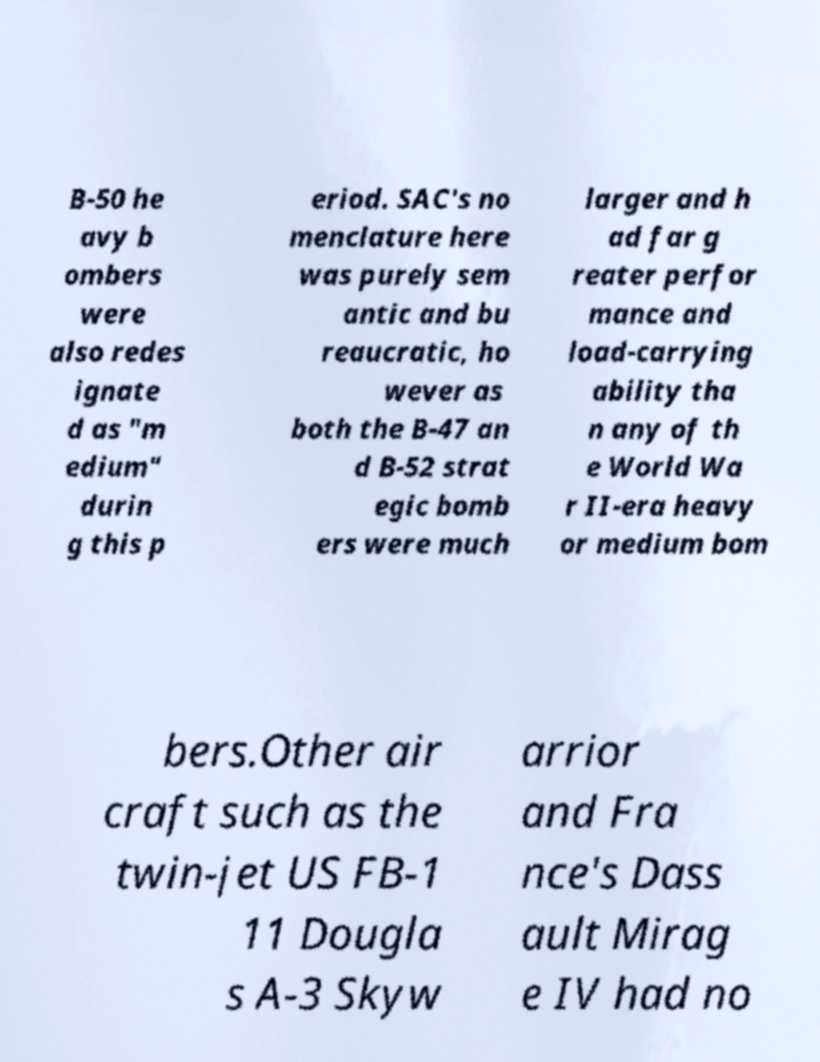Could you extract and type out the text from this image? B-50 he avy b ombers were also redes ignate d as "m edium" durin g this p eriod. SAC's no menclature here was purely sem antic and bu reaucratic, ho wever as both the B-47 an d B-52 strat egic bomb ers were much larger and h ad far g reater perfor mance and load-carrying ability tha n any of th e World Wa r II-era heavy or medium bom bers.Other air craft such as the twin-jet US FB-1 11 Dougla s A-3 Skyw arrior and Fra nce's Dass ault Mirag e IV had no 